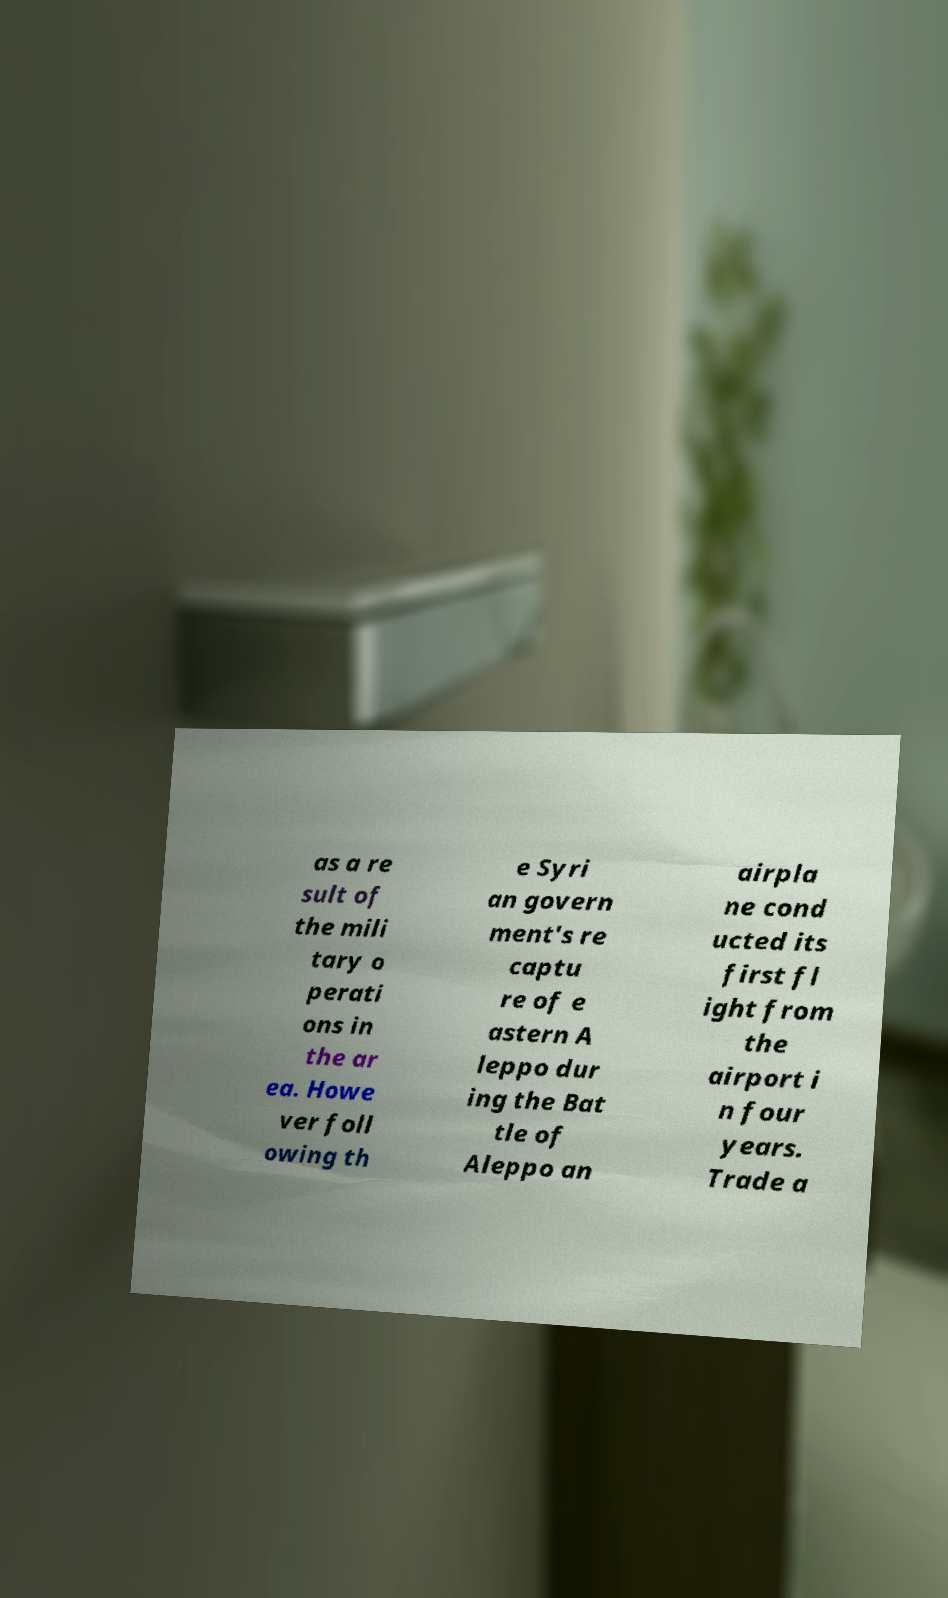There's text embedded in this image that I need extracted. Can you transcribe it verbatim? as a re sult of the mili tary o perati ons in the ar ea. Howe ver foll owing th e Syri an govern ment's re captu re of e astern A leppo dur ing the Bat tle of Aleppo an airpla ne cond ucted its first fl ight from the airport i n four years. Trade a 